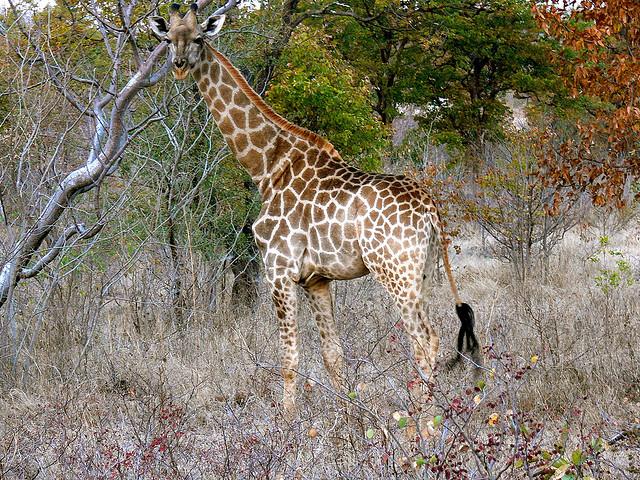What animal is in the picture?
Concise answer only. Giraffe. What color is the tip of the giraffes tail?
Be succinct. Black. Where was the picture taken of the giraffe?
Write a very short answer. In wild. What color is the grass?
Be succinct. Brown. What month was this picture taken in?
Be succinct. August. 